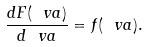Convert formula to latex. <formula><loc_0><loc_0><loc_500><loc_500>\frac { d F ( \ v a ) } { d \ v a } = f ( \ v a ) .</formula> 